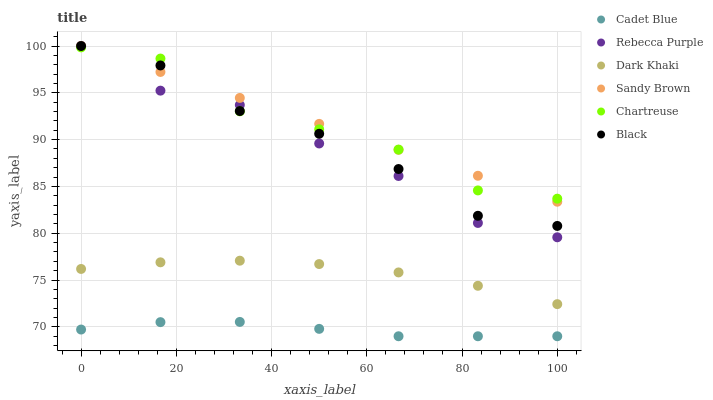Does Cadet Blue have the minimum area under the curve?
Answer yes or no. Yes. Does Sandy Brown have the maximum area under the curve?
Answer yes or no. Yes. Does Dark Khaki have the minimum area under the curve?
Answer yes or no. No. Does Dark Khaki have the maximum area under the curve?
Answer yes or no. No. Is Sandy Brown the smoothest?
Answer yes or no. Yes. Is Chartreuse the roughest?
Answer yes or no. Yes. Is Dark Khaki the smoothest?
Answer yes or no. No. Is Dark Khaki the roughest?
Answer yes or no. No. Does Cadet Blue have the lowest value?
Answer yes or no. Yes. Does Dark Khaki have the lowest value?
Answer yes or no. No. Does Sandy Brown have the highest value?
Answer yes or no. Yes. Does Dark Khaki have the highest value?
Answer yes or no. No. Is Cadet Blue less than Rebecca Purple?
Answer yes or no. Yes. Is Black greater than Cadet Blue?
Answer yes or no. Yes. Does Chartreuse intersect Rebecca Purple?
Answer yes or no. Yes. Is Chartreuse less than Rebecca Purple?
Answer yes or no. No. Is Chartreuse greater than Rebecca Purple?
Answer yes or no. No. Does Cadet Blue intersect Rebecca Purple?
Answer yes or no. No. 